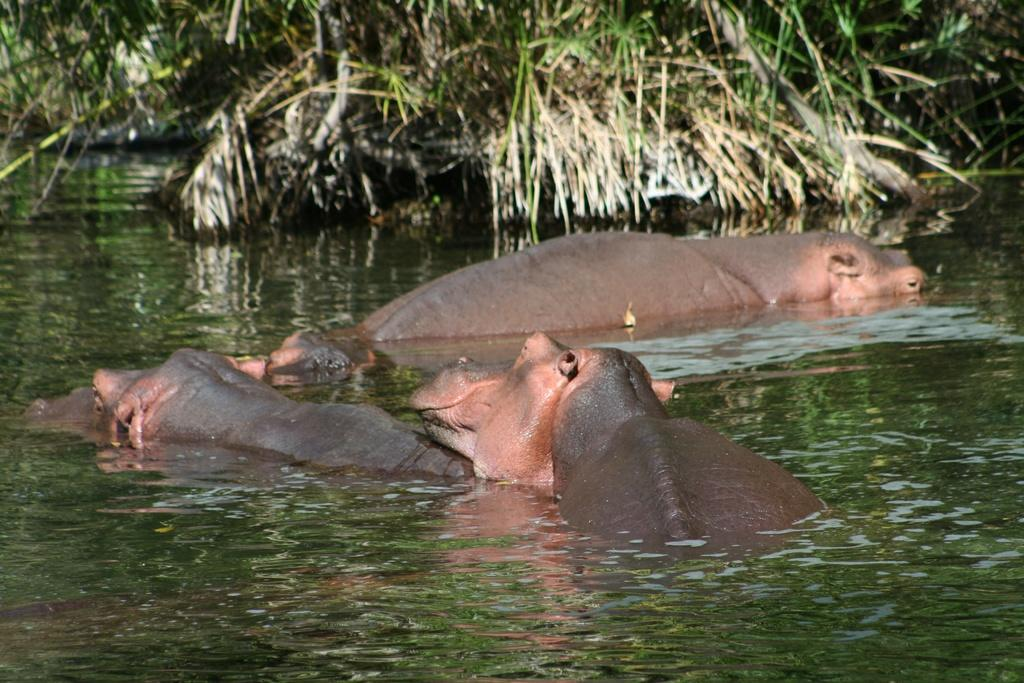What animals can be seen in the water in the image? There are hippopotamuses in the water in the image. What can be seen in the background of the image? There are plants in the background of the image. What type of box is being used to store the morning in the image? There is no box or reference to morning in the image; it features hippopotamuses in the water and plants in the background. 